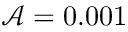Convert formula to latex. <formula><loc_0><loc_0><loc_500><loc_500>\mathcal { A } = 0 . 0 0 1</formula> 